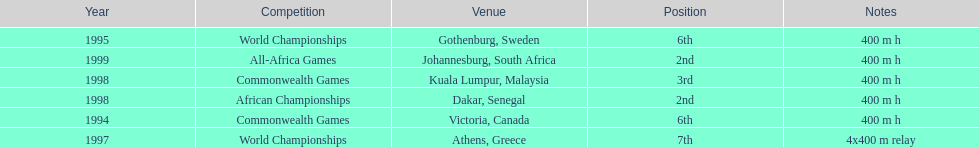What is the last competition on the chart? All-Africa Games. 